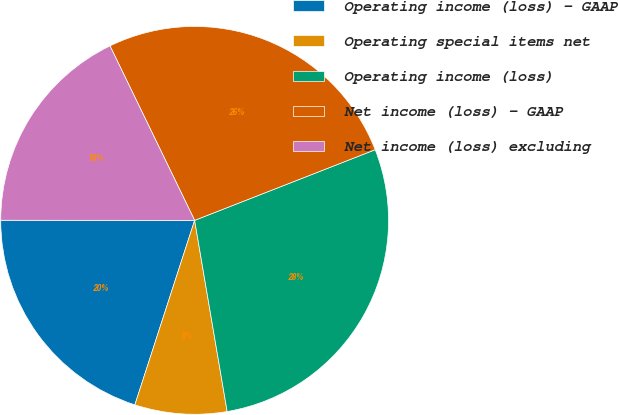Convert chart. <chart><loc_0><loc_0><loc_500><loc_500><pie_chart><fcel>Operating income (loss) - GAAP<fcel>Operating special items net<fcel>Operating income (loss)<fcel>Net income (loss) - GAAP<fcel>Net income (loss) excluding<nl><fcel>20.02%<fcel>7.67%<fcel>28.25%<fcel>26.25%<fcel>17.8%<nl></chart> 